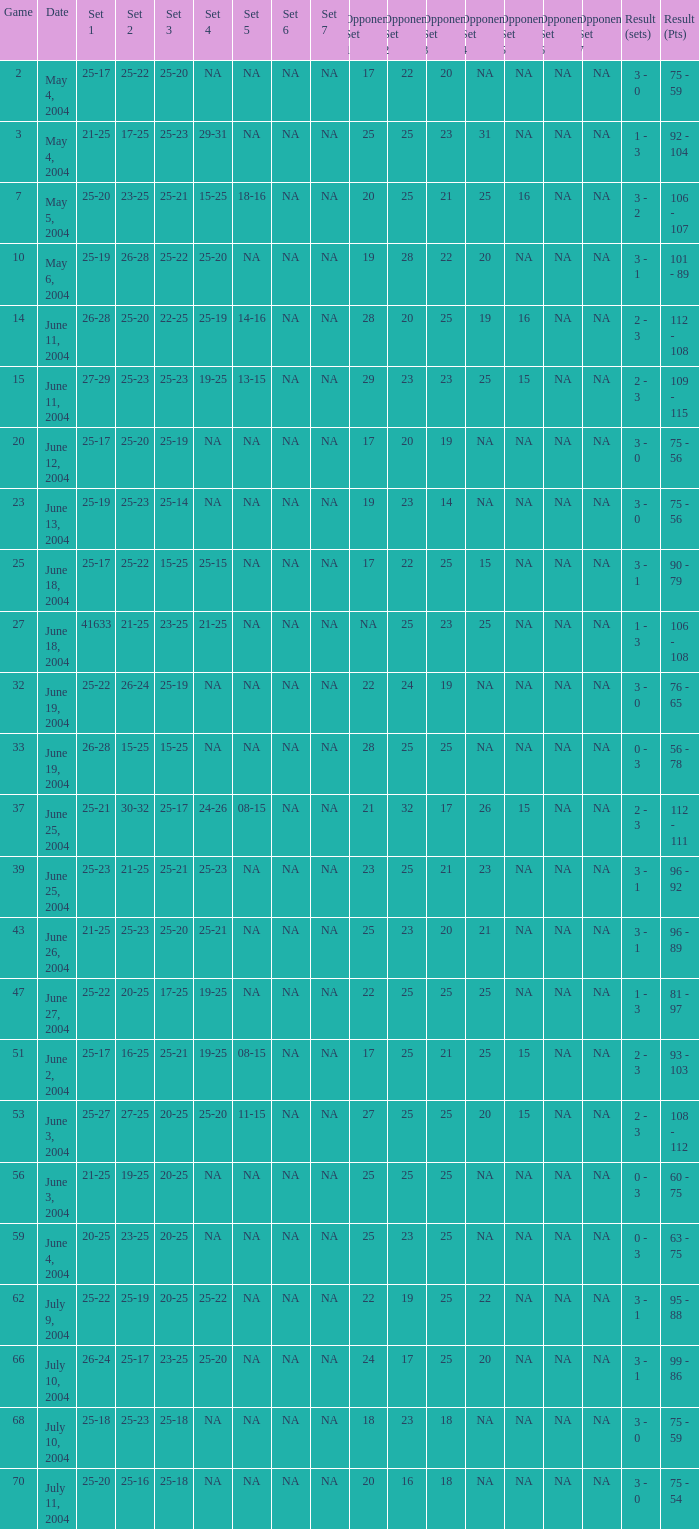What is the result of the game with a set 1 of 26-24? 99 - 86. 